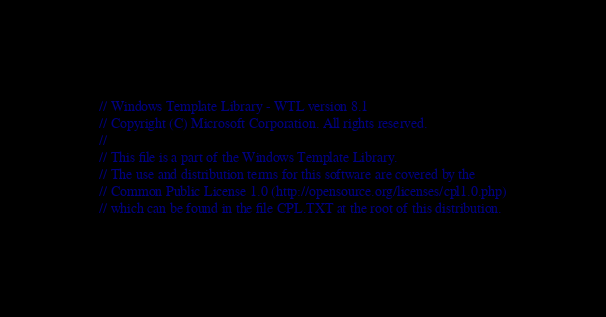<code> <loc_0><loc_0><loc_500><loc_500><_C_>// Windows Template Library - WTL version 8.1
// Copyright (C) Microsoft Corporation. All rights reserved.
//
// This file is a part of the Windows Template Library.
// The use and distribution terms for this software are covered by the
// Common Public License 1.0 (http://opensource.org/licenses/cpl1.0.php)
// which can be found in the file CPL.TXT at the root of this distribution.</code> 